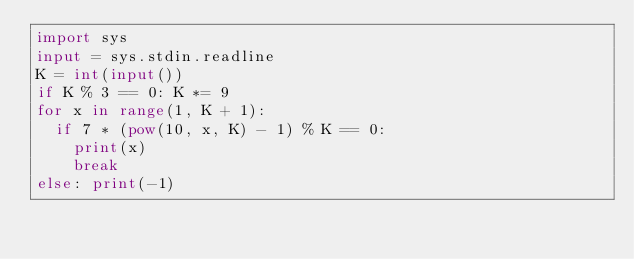<code> <loc_0><loc_0><loc_500><loc_500><_Python_>import sys
input = sys.stdin.readline
K = int(input())
if K % 3 == 0: K *= 9
for x in range(1, K + 1):
  if 7 * (pow(10, x, K) - 1) % K == 0:
    print(x)
    break
else: print(-1)</code> 